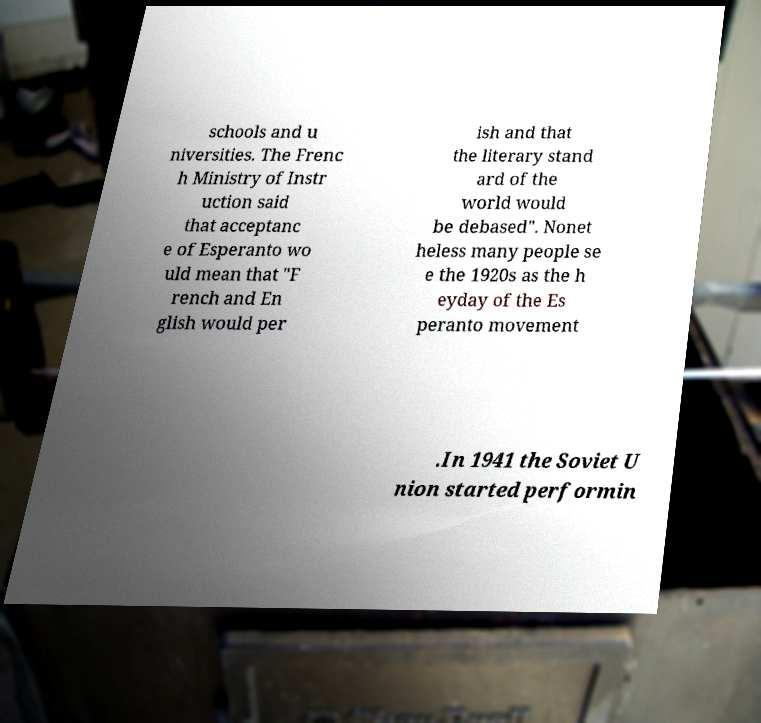For documentation purposes, I need the text within this image transcribed. Could you provide that? schools and u niversities. The Frenc h Ministry of Instr uction said that acceptanc e of Esperanto wo uld mean that "F rench and En glish would per ish and that the literary stand ard of the world would be debased". Nonet heless many people se e the 1920s as the h eyday of the Es peranto movement .In 1941 the Soviet U nion started performin 